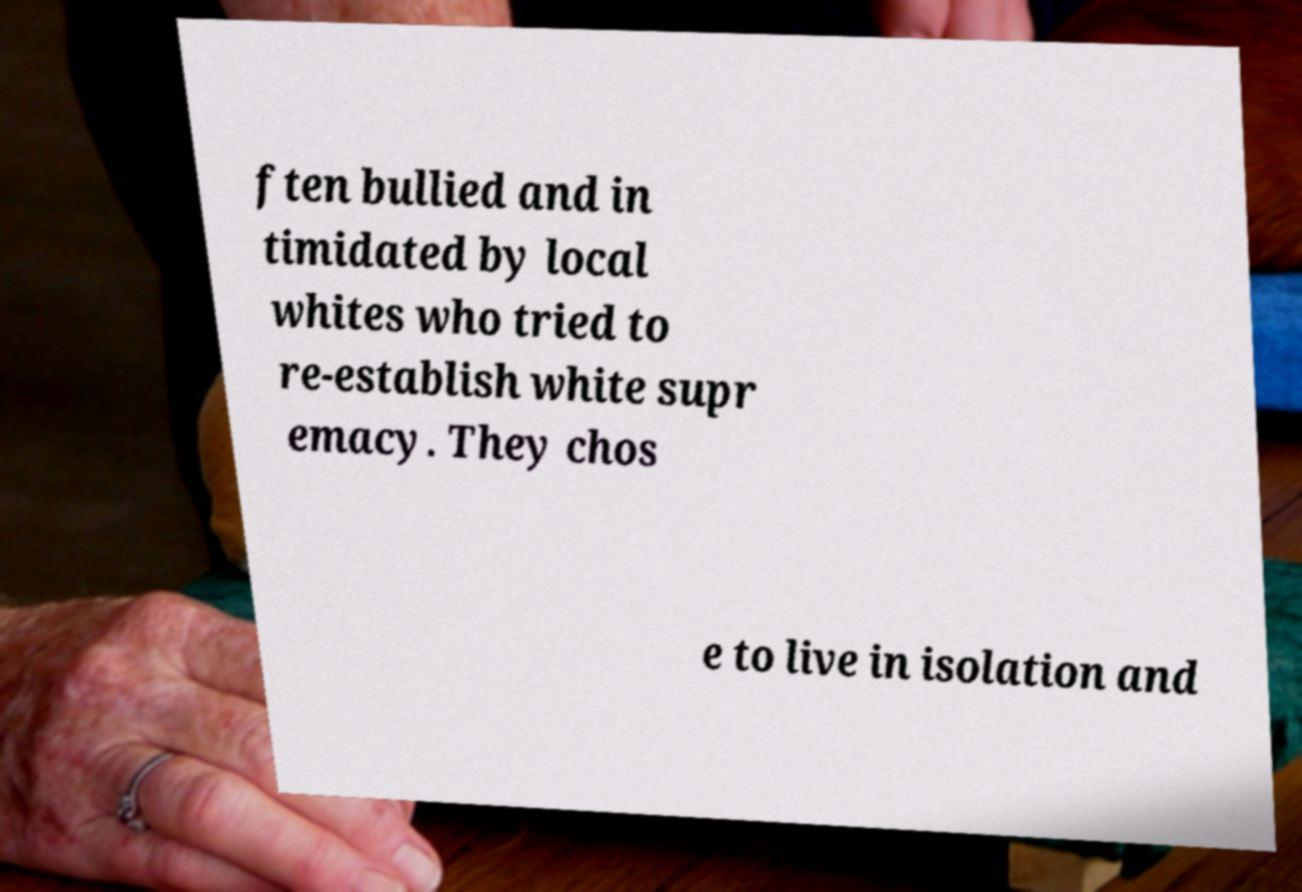I need the written content from this picture converted into text. Can you do that? ften bullied and in timidated by local whites who tried to re-establish white supr emacy. They chos e to live in isolation and 